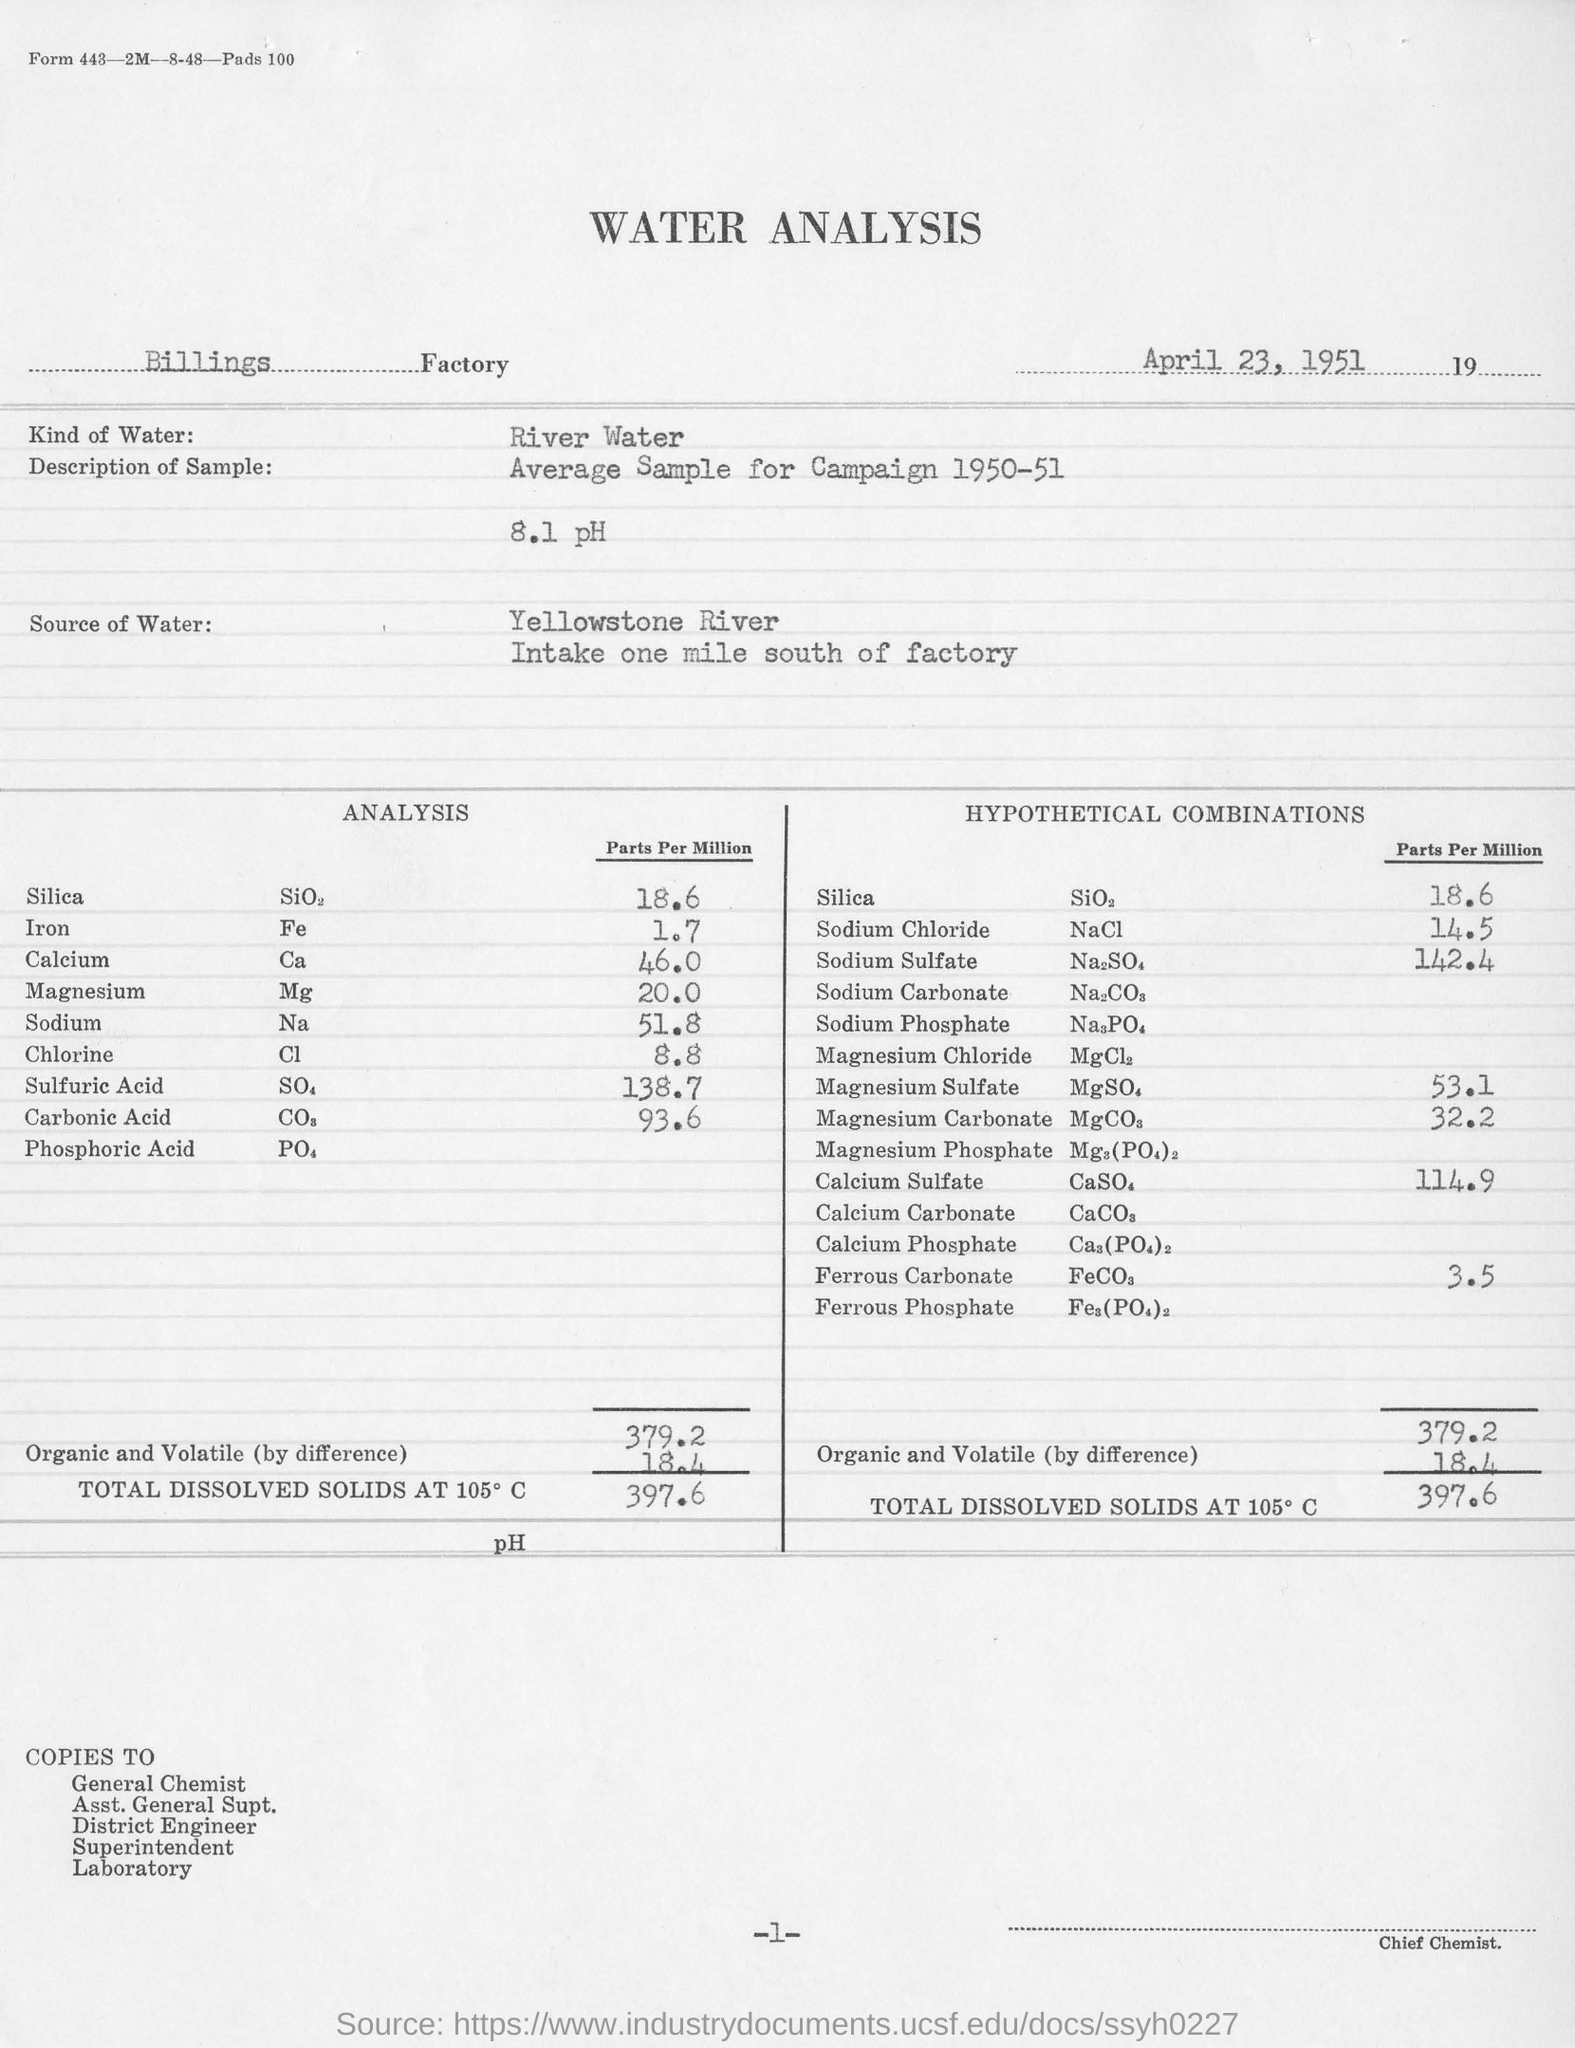Give some essential details in this illustration. The date mentioned in the water analysis is April 23, 1951. The concentration of sodium chloride in the analysis was measured to be 14.5 parts per million. The analysis is conducted at Billings Factory. The analysis utilizes river water as the source of water for the experiment. The concentration of chlorine in parts per million in the analysis is 8.8. 